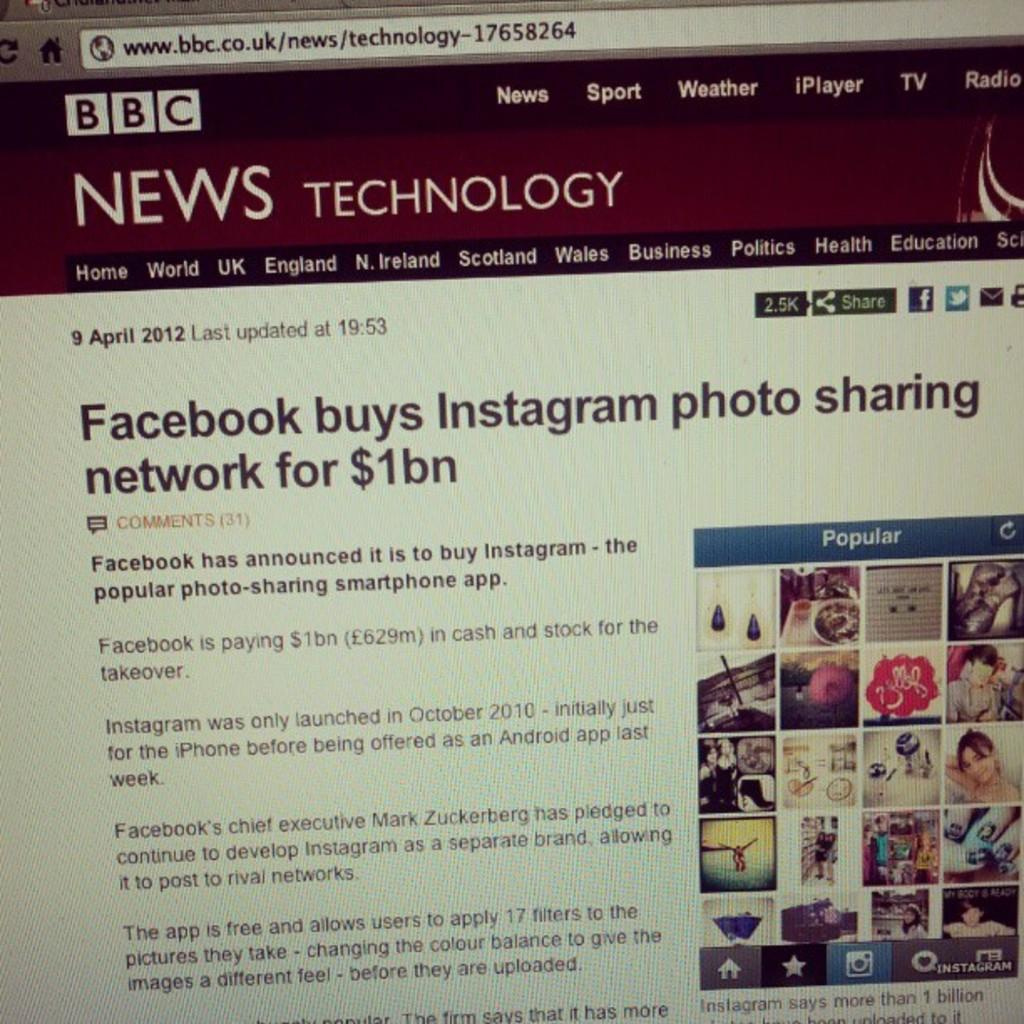Provide a one-sentence caption for the provided image. A web page from the BBC has an article about Facebook buying Instagram. 